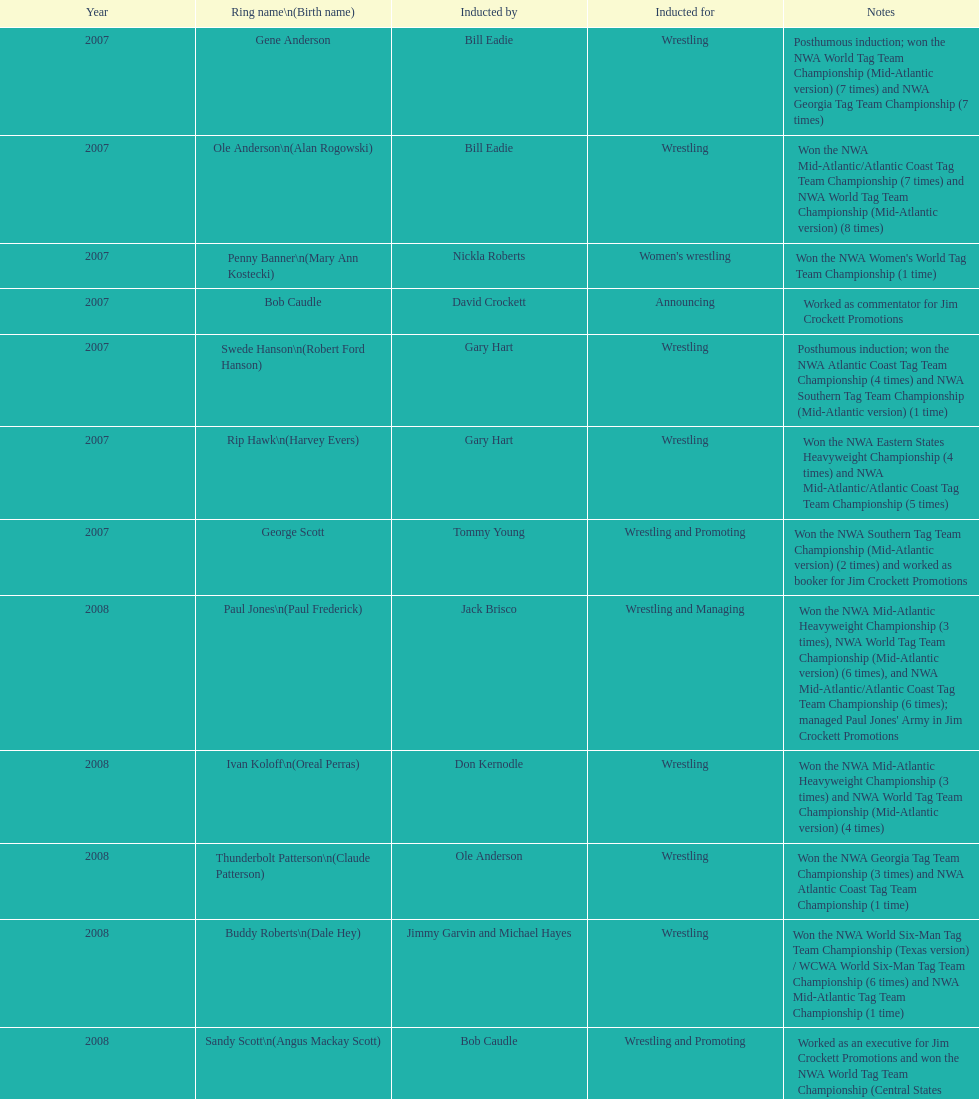Who joined after royal's induction? Lance Russell. 